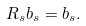Convert formula to latex. <formula><loc_0><loc_0><loc_500><loc_500>R _ { s } b _ { s } = b _ { s } .</formula> 